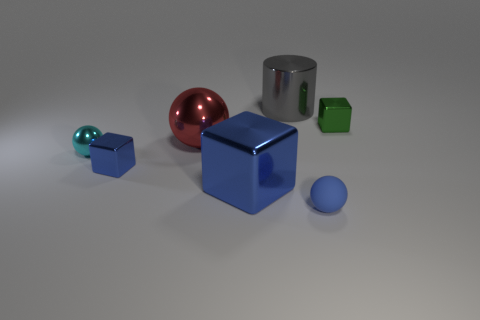What number of blue objects are metallic spheres or tiny shiny things?
Your answer should be compact. 1. There is a tiny object behind the cyan shiny sphere; does it have the same shape as the small blue thing that is on the left side of the shiny cylinder?
Your answer should be compact. Yes. There is a matte sphere; is its color the same as the small block on the left side of the blue rubber object?
Offer a terse response. Yes. There is a metal thing that is on the right side of the matte thing; does it have the same color as the rubber ball?
Give a very brief answer. No. How many things are gray objects or small balls to the left of the matte sphere?
Your response must be concise. 2. There is a sphere that is in front of the red object and on the right side of the small metallic ball; what material is it?
Ensure brevity in your answer.  Rubber. There is a small blue thing that is to the right of the big gray metallic cylinder; what is its material?
Provide a succinct answer. Rubber. What is the color of the tiny ball that is made of the same material as the gray object?
Offer a terse response. Cyan. There is a blue rubber thing; is its shape the same as the big shiny thing that is on the left side of the large blue metal object?
Offer a terse response. Yes. Are there any green cubes behind the tiny cyan sphere?
Your answer should be compact. Yes. 